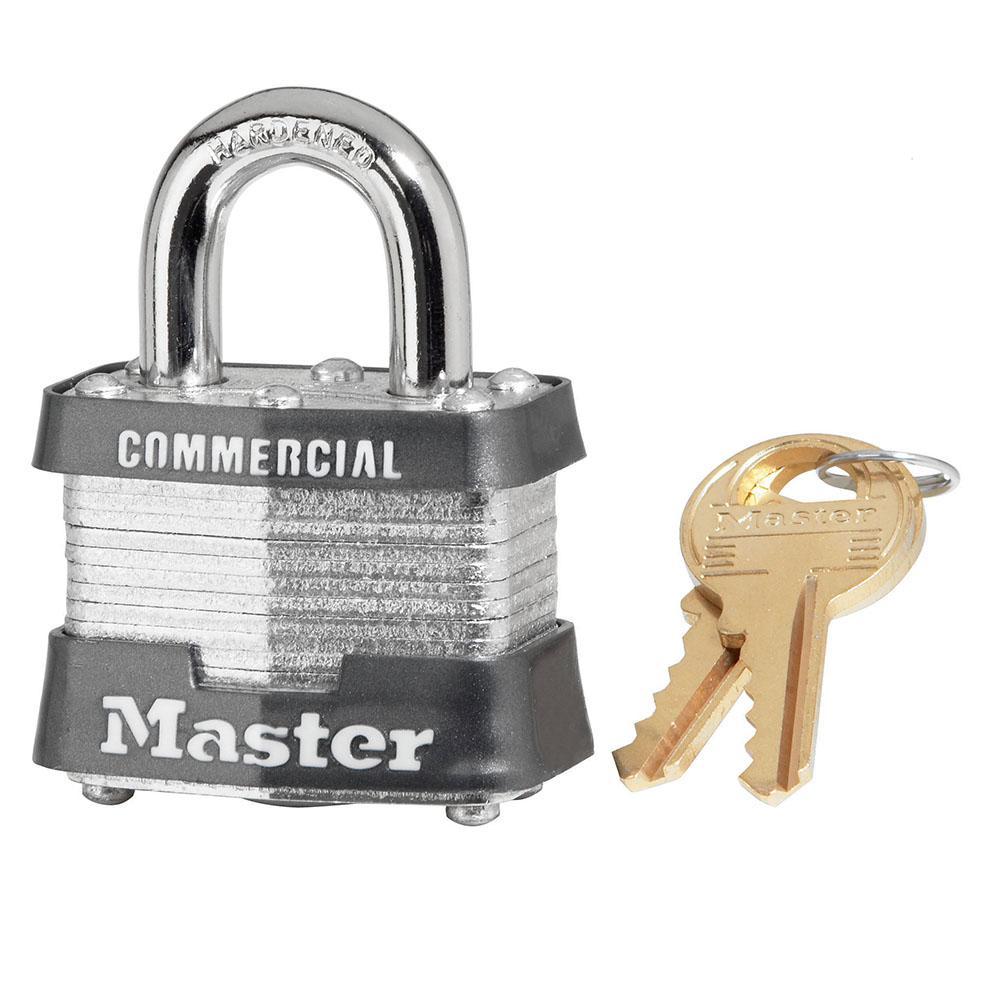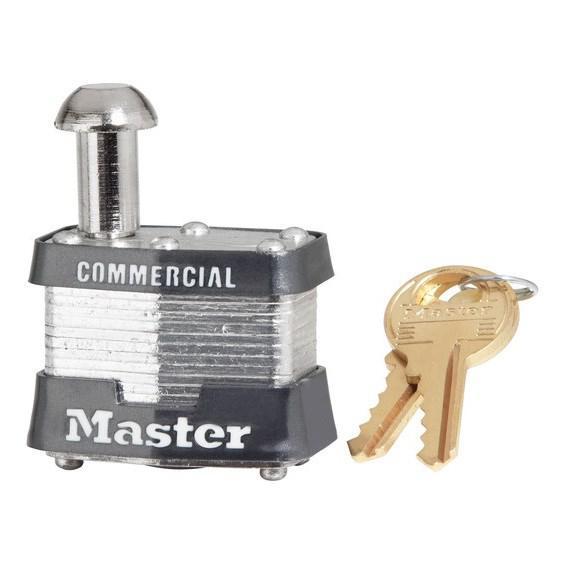The first image is the image on the left, the second image is the image on the right. Assess this claim about the two images: "Each image contains only one lock, and each lock has a silver loop at the top.". Correct or not? Answer yes or no. No. The first image is the image on the left, the second image is the image on the right. Assess this claim about the two images: "Two locks each have two keys and the same logo designs, but have differences in the lock mechanisms above the bases.". Correct or not? Answer yes or no. Yes. 